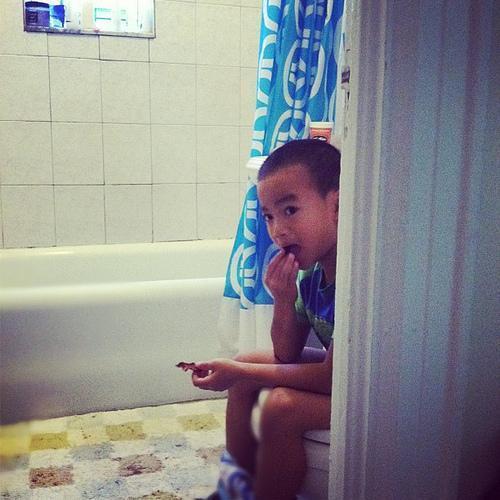How many people are in the photo?
Give a very brief answer. 1. How many children are pictured here?
Give a very brief answer. 1. 